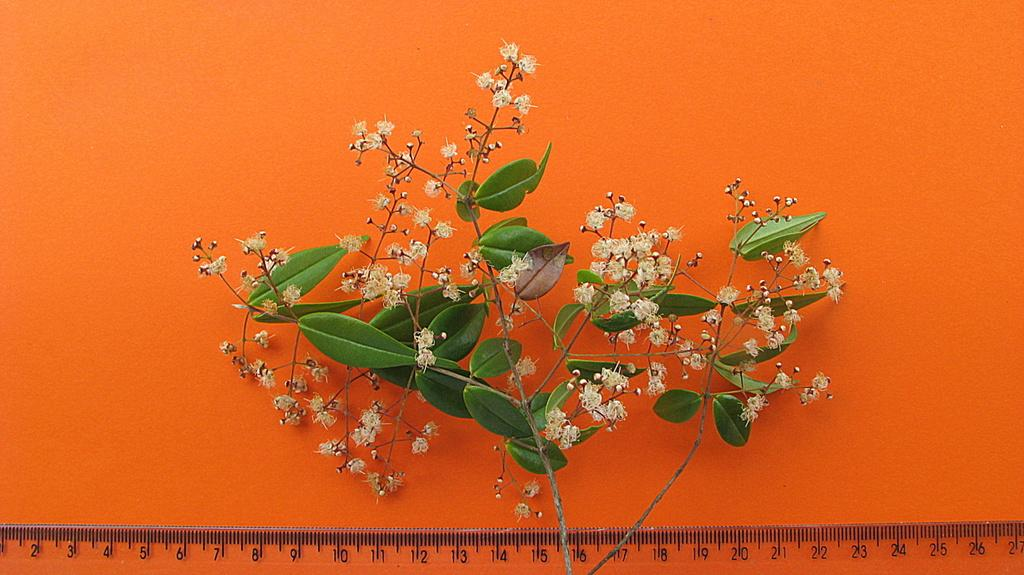What type of living organism can be seen in the image? There is a plant in the image. What object is located at the bottom of the image? There is a scale at the bottom of the image. What color is the background of the image? The background of the image is orange in color. What type of plastic material can be seen on the plant in the image? There is no plastic material present on the plant in the image. Can you describe the beetle that is crawling on the scale in the image? There is no beetle present on the scale or anywhere else in the image. 